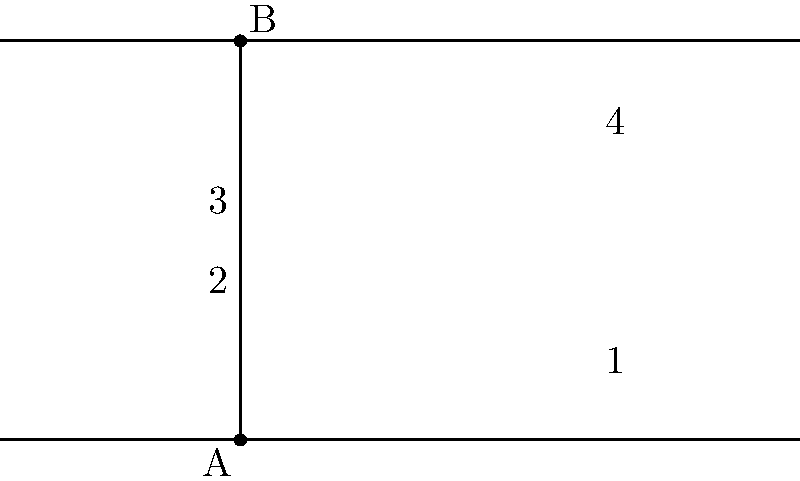In the figure above, two parallel lines are intersected by a transversal. If the measure of angle 1 is $35°$, what is the measure of angle 3? Let's approach this step-by-step:

1) First, recall that when a transversal intersects two parallel lines, corresponding angles are congruent. In this case, angles 1 and 3 are corresponding angles.

2) The theorem states: If two parallel lines are cut by a transversal, then the corresponding angles are congruent.

3) Therefore, we can conclude that:

   $$\text{measure of angle 1} = \text{measure of angle 3}$$

4) We are given that the measure of angle 1 is $35°$.

5) Thus, we can directly state that the measure of angle 3 is also $35°$.

This solution relies on the fundamental properties of parallel lines and transversals, demonstrating how geometric theorems can be applied to solve problems efficiently.
Answer: $35°$ 